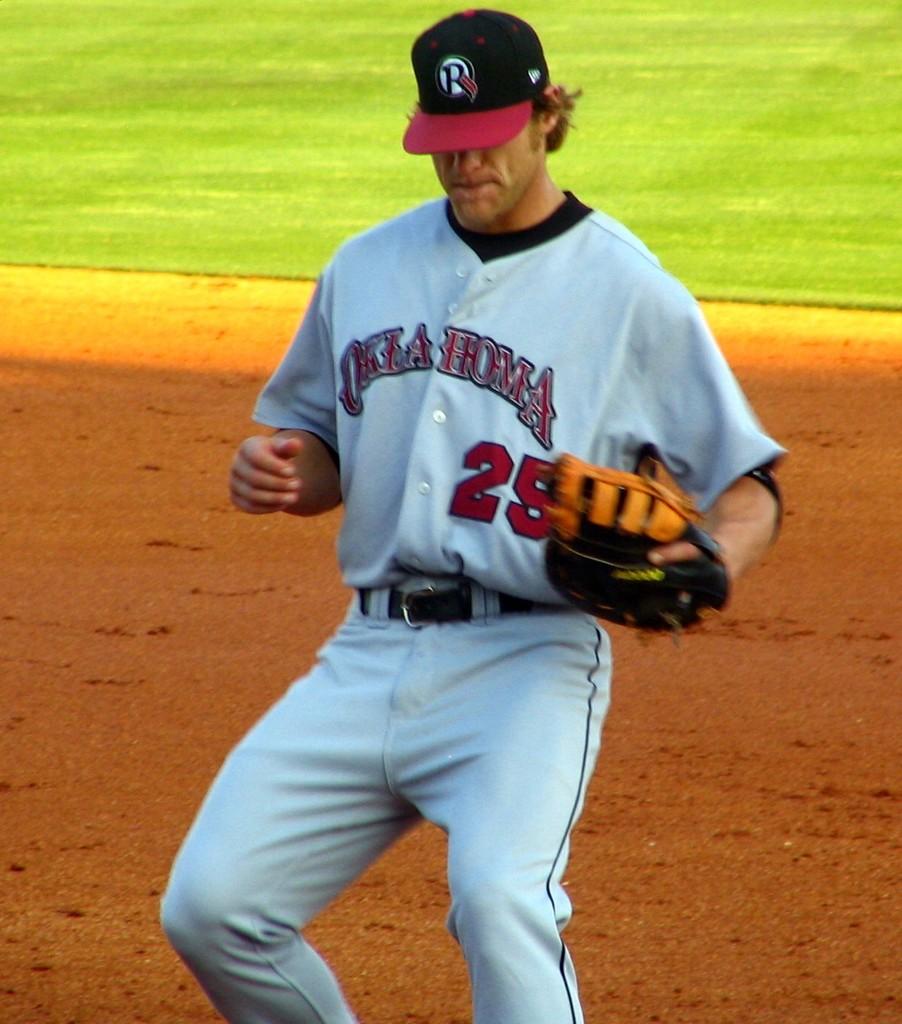What number is on his jersey?
Ensure brevity in your answer.  25. 